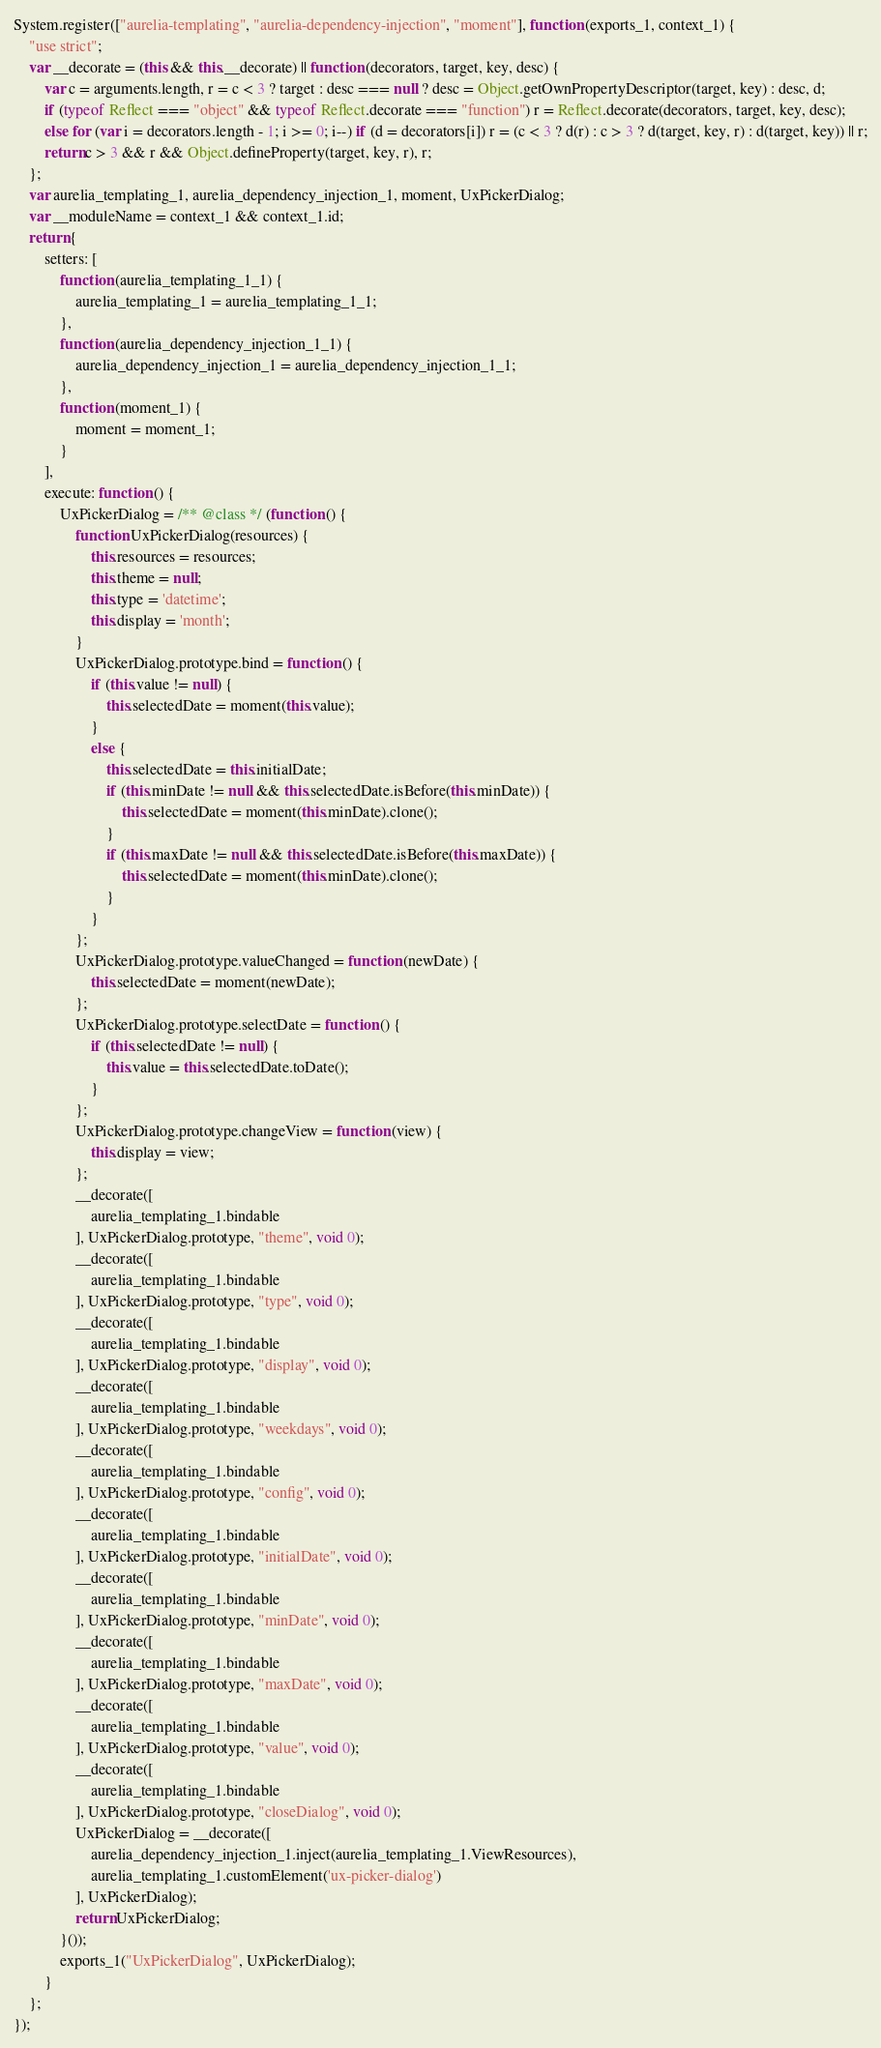Convert code to text. <code><loc_0><loc_0><loc_500><loc_500><_JavaScript_>System.register(["aurelia-templating", "aurelia-dependency-injection", "moment"], function (exports_1, context_1) {
    "use strict";
    var __decorate = (this && this.__decorate) || function (decorators, target, key, desc) {
        var c = arguments.length, r = c < 3 ? target : desc === null ? desc = Object.getOwnPropertyDescriptor(target, key) : desc, d;
        if (typeof Reflect === "object" && typeof Reflect.decorate === "function") r = Reflect.decorate(decorators, target, key, desc);
        else for (var i = decorators.length - 1; i >= 0; i--) if (d = decorators[i]) r = (c < 3 ? d(r) : c > 3 ? d(target, key, r) : d(target, key)) || r;
        return c > 3 && r && Object.defineProperty(target, key, r), r;
    };
    var aurelia_templating_1, aurelia_dependency_injection_1, moment, UxPickerDialog;
    var __moduleName = context_1 && context_1.id;
    return {
        setters: [
            function (aurelia_templating_1_1) {
                aurelia_templating_1 = aurelia_templating_1_1;
            },
            function (aurelia_dependency_injection_1_1) {
                aurelia_dependency_injection_1 = aurelia_dependency_injection_1_1;
            },
            function (moment_1) {
                moment = moment_1;
            }
        ],
        execute: function () {
            UxPickerDialog = /** @class */ (function () {
                function UxPickerDialog(resources) {
                    this.resources = resources;
                    this.theme = null;
                    this.type = 'datetime';
                    this.display = 'month';
                }
                UxPickerDialog.prototype.bind = function () {
                    if (this.value != null) {
                        this.selectedDate = moment(this.value);
                    }
                    else {
                        this.selectedDate = this.initialDate;
                        if (this.minDate != null && this.selectedDate.isBefore(this.minDate)) {
                            this.selectedDate = moment(this.minDate).clone();
                        }
                        if (this.maxDate != null && this.selectedDate.isBefore(this.maxDate)) {
                            this.selectedDate = moment(this.minDate).clone();
                        }
                    }
                };
                UxPickerDialog.prototype.valueChanged = function (newDate) {
                    this.selectedDate = moment(newDate);
                };
                UxPickerDialog.prototype.selectDate = function () {
                    if (this.selectedDate != null) {
                        this.value = this.selectedDate.toDate();
                    }
                };
                UxPickerDialog.prototype.changeView = function (view) {
                    this.display = view;
                };
                __decorate([
                    aurelia_templating_1.bindable
                ], UxPickerDialog.prototype, "theme", void 0);
                __decorate([
                    aurelia_templating_1.bindable
                ], UxPickerDialog.prototype, "type", void 0);
                __decorate([
                    aurelia_templating_1.bindable
                ], UxPickerDialog.prototype, "display", void 0);
                __decorate([
                    aurelia_templating_1.bindable
                ], UxPickerDialog.prototype, "weekdays", void 0);
                __decorate([
                    aurelia_templating_1.bindable
                ], UxPickerDialog.prototype, "config", void 0);
                __decorate([
                    aurelia_templating_1.bindable
                ], UxPickerDialog.prototype, "initialDate", void 0);
                __decorate([
                    aurelia_templating_1.bindable
                ], UxPickerDialog.prototype, "minDate", void 0);
                __decorate([
                    aurelia_templating_1.bindable
                ], UxPickerDialog.prototype, "maxDate", void 0);
                __decorate([
                    aurelia_templating_1.bindable
                ], UxPickerDialog.prototype, "value", void 0);
                __decorate([
                    aurelia_templating_1.bindable
                ], UxPickerDialog.prototype, "closeDialog", void 0);
                UxPickerDialog = __decorate([
                    aurelia_dependency_injection_1.inject(aurelia_templating_1.ViewResources),
                    aurelia_templating_1.customElement('ux-picker-dialog')
                ], UxPickerDialog);
                return UxPickerDialog;
            }());
            exports_1("UxPickerDialog", UxPickerDialog);
        }
    };
});
</code> 